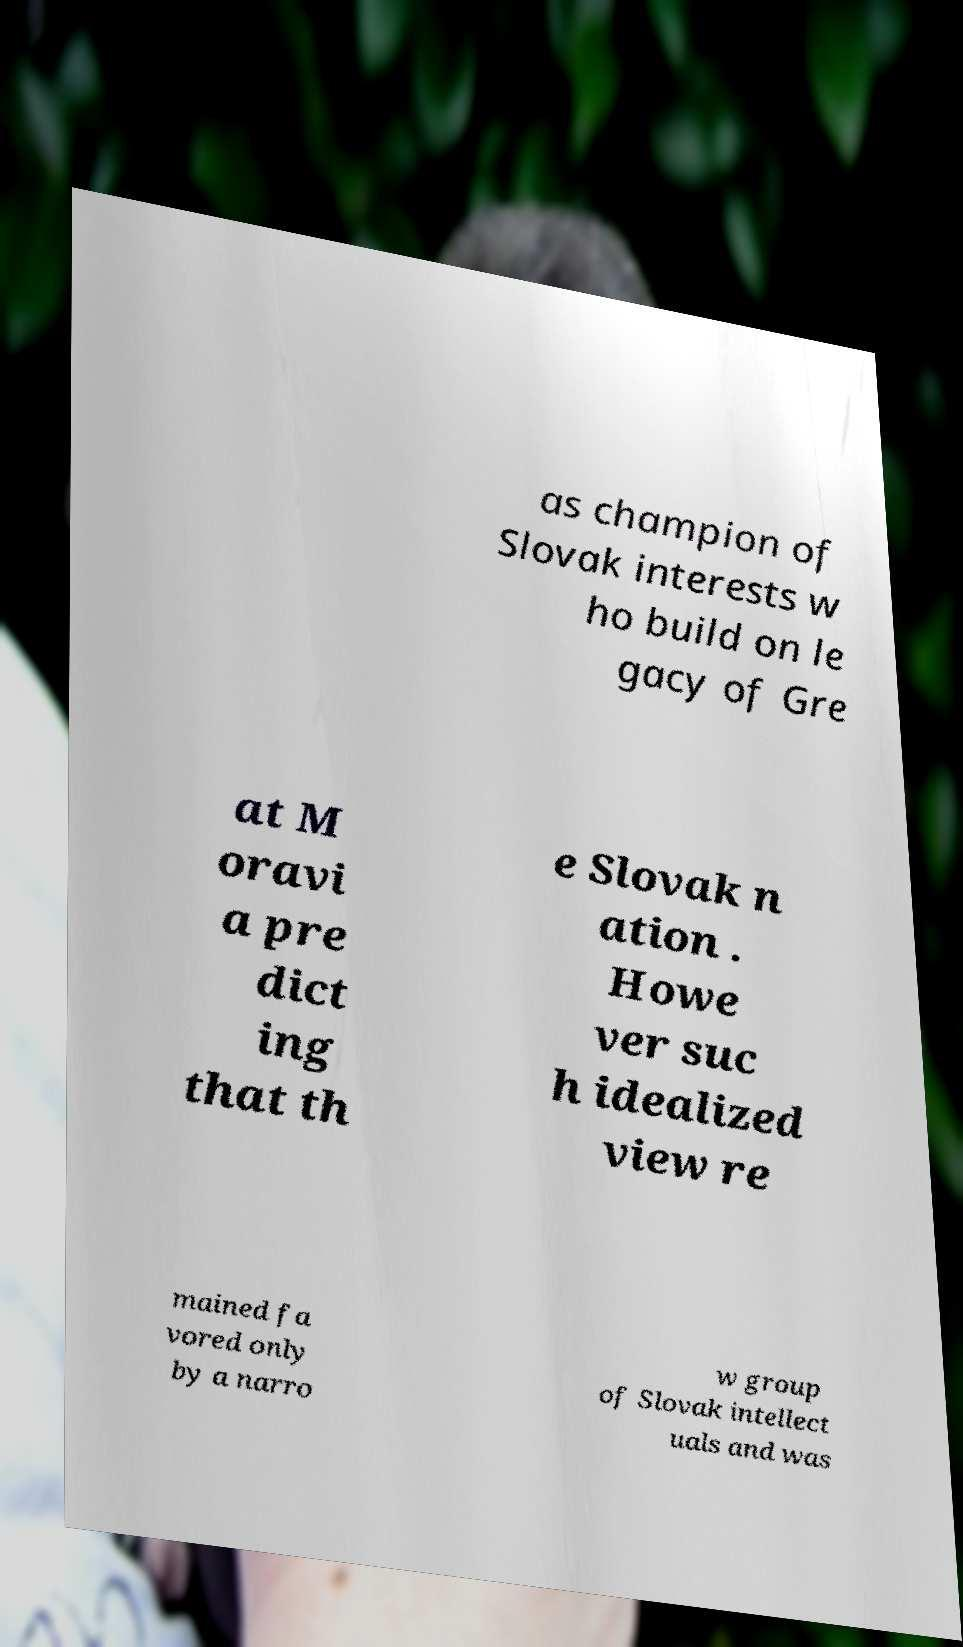Please identify and transcribe the text found in this image. as champion of Slovak interests w ho build on le gacy of Gre at M oravi a pre dict ing that th e Slovak n ation . Howe ver suc h idealized view re mained fa vored only by a narro w group of Slovak intellect uals and was 